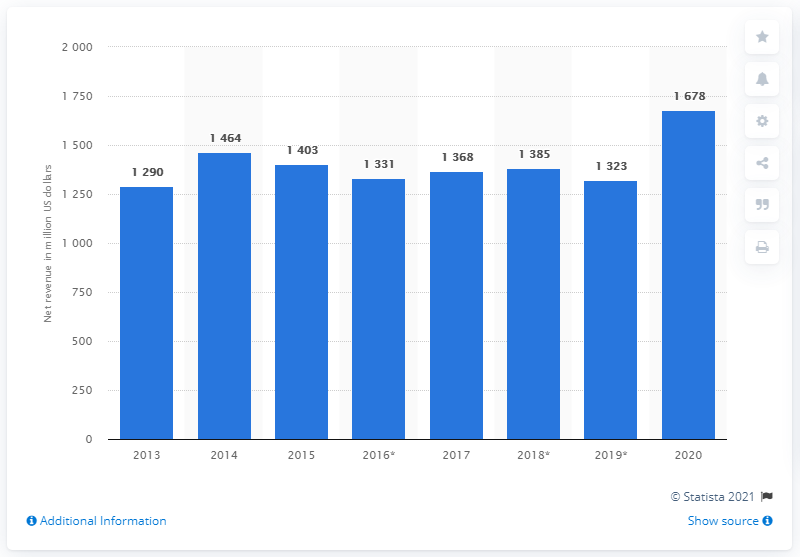Specify some key components in this picture. In 2013, eBay's net revenue in the UK was 1678. 